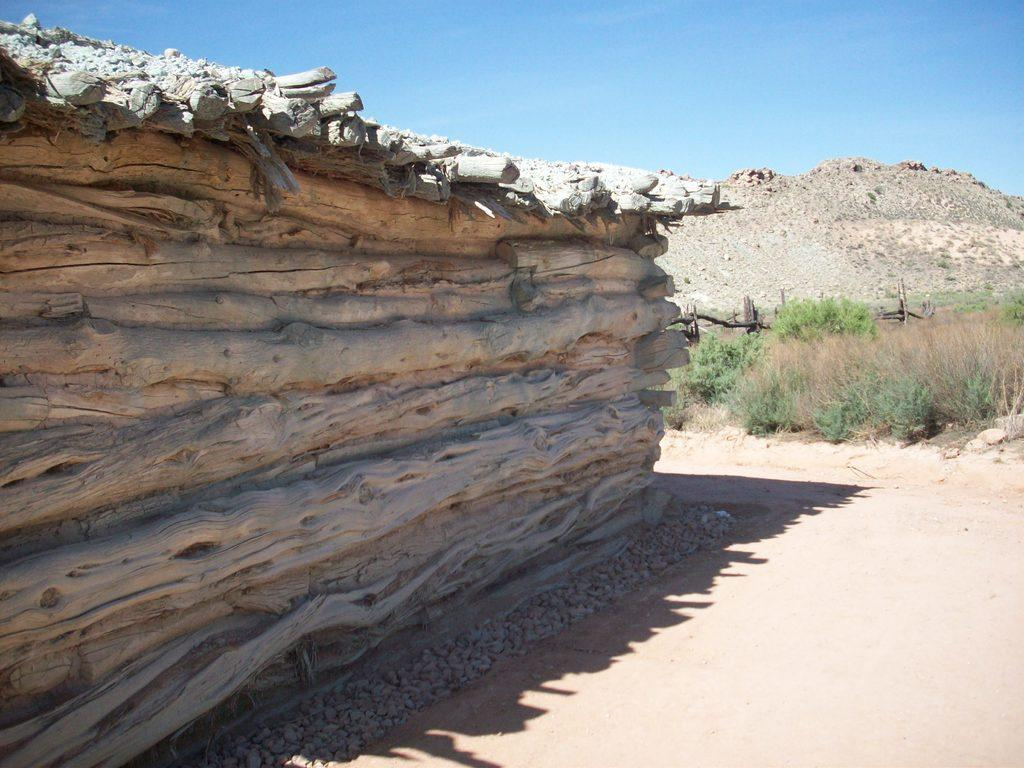What type of natural elements can be seen in the image? There are stones in the image. What type of structure is present in the image? There is a wooden house in the image. What type of vegetation is visible behind the house? There are plants behind the house. What can be seen in the distance behind the house? There is a hill visible in the background. What is visible in the sky in the image? The sky is visible in the background. What type of zephyr can be seen blowing through the jar in the image? There is no jar or zephyr present in the image. What type of flower is growing near the wooden house in the image? There is no flower visible near the wooden house in the image. 